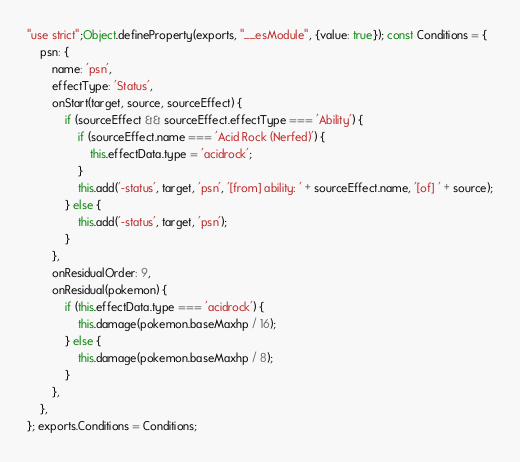Convert code to text. <code><loc_0><loc_0><loc_500><loc_500><_JavaScript_>"use strict";Object.defineProperty(exports, "__esModule", {value: true}); const Conditions = {
	psn: {
		name: 'psn',
		effectType: 'Status',
		onStart(target, source, sourceEffect) {
			if (sourceEffect && sourceEffect.effectType === 'Ability') {
				if (sourceEffect.name === 'Acid Rock (Nerfed)') {
					this.effectData.type = 'acidrock';
				}
				this.add('-status', target, 'psn', '[from] ability: ' + sourceEffect.name, '[of] ' + source);
			} else {
				this.add('-status', target, 'psn');
			}
		},
		onResidualOrder: 9,
		onResidual(pokemon) {
			if (this.effectData.type === 'acidrock') {
				this.damage(pokemon.baseMaxhp / 16);
			} else {
				this.damage(pokemon.baseMaxhp / 8);
			}
		},
	},
}; exports.Conditions = Conditions;
</code> 